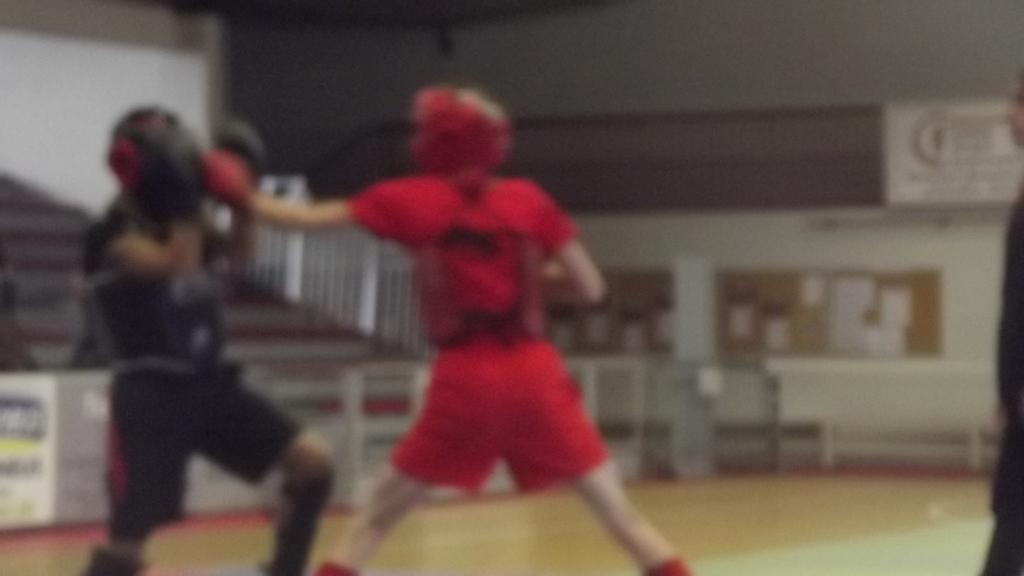What is the overall quality of the image? The image is blurry. How many people are present in the image? There are two people in the image. What are the two people doing in the image? The two people appear to be fighting with each other. Where is the fighting taking place? The fighting is taking place on a ground. What type of train can be seen in the background of the image? There is no train present in the image; it is focused on the two people fighting. Can you tell me how much rice is being used in the image? There is no rice present in the image. 